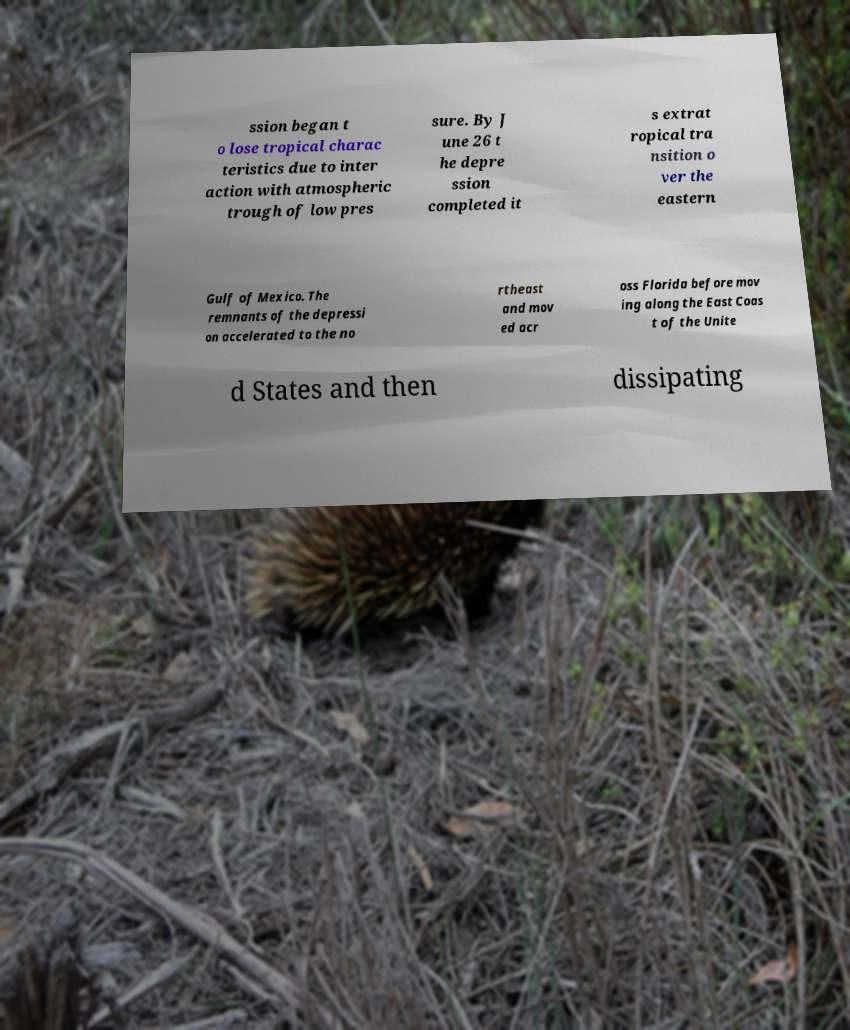Could you extract and type out the text from this image? ssion began t o lose tropical charac teristics due to inter action with atmospheric trough of low pres sure. By J une 26 t he depre ssion completed it s extrat ropical tra nsition o ver the eastern Gulf of Mexico. The remnants of the depressi on accelerated to the no rtheast and mov ed acr oss Florida before mov ing along the East Coas t of the Unite d States and then dissipating 